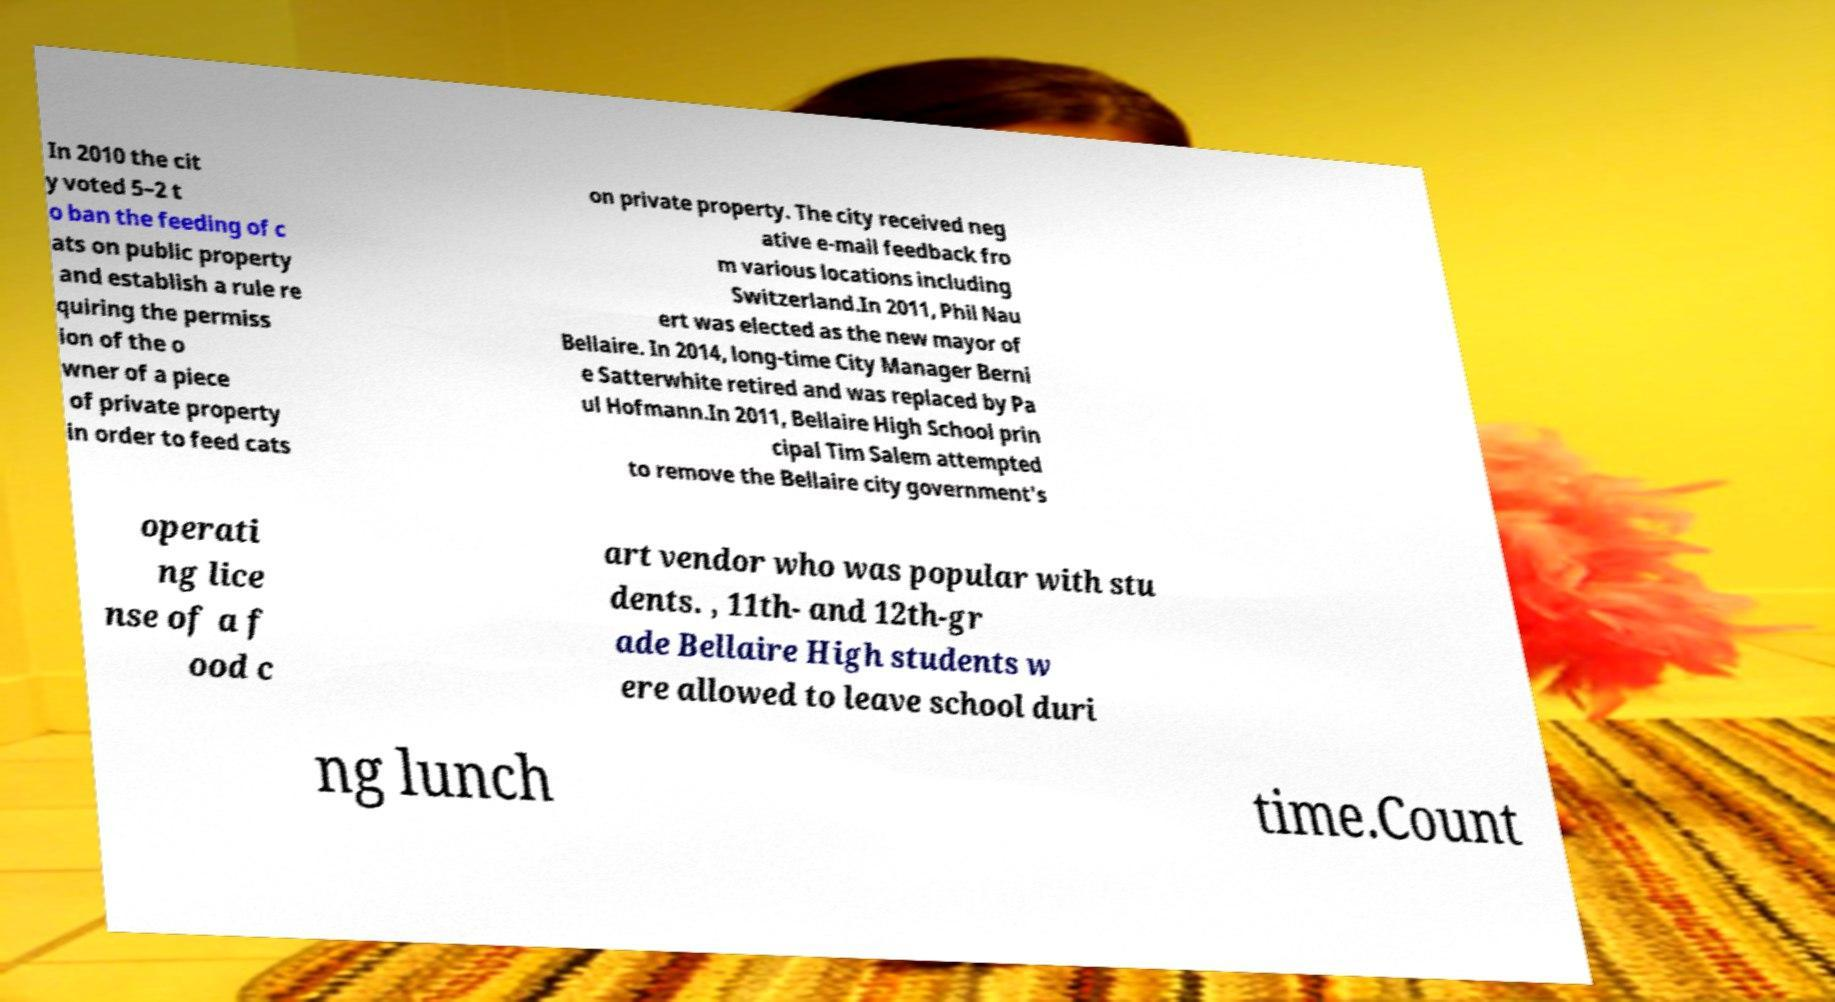I need the written content from this picture converted into text. Can you do that? In 2010 the cit y voted 5–2 t o ban the feeding of c ats on public property and establish a rule re quiring the permiss ion of the o wner of a piece of private property in order to feed cats on private property. The city received neg ative e-mail feedback fro m various locations including Switzerland.In 2011, Phil Nau ert was elected as the new mayor of Bellaire. In 2014, long-time City Manager Berni e Satterwhite retired and was replaced by Pa ul Hofmann.In 2011, Bellaire High School prin cipal Tim Salem attempted to remove the Bellaire city government's operati ng lice nse of a f ood c art vendor who was popular with stu dents. , 11th- and 12th-gr ade Bellaire High students w ere allowed to leave school duri ng lunch time.Count 